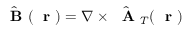<formula> <loc_0><loc_0><loc_500><loc_500>\hat { B } ( r ) = \nabla \times \hat { A } _ { T } ( r )</formula> 